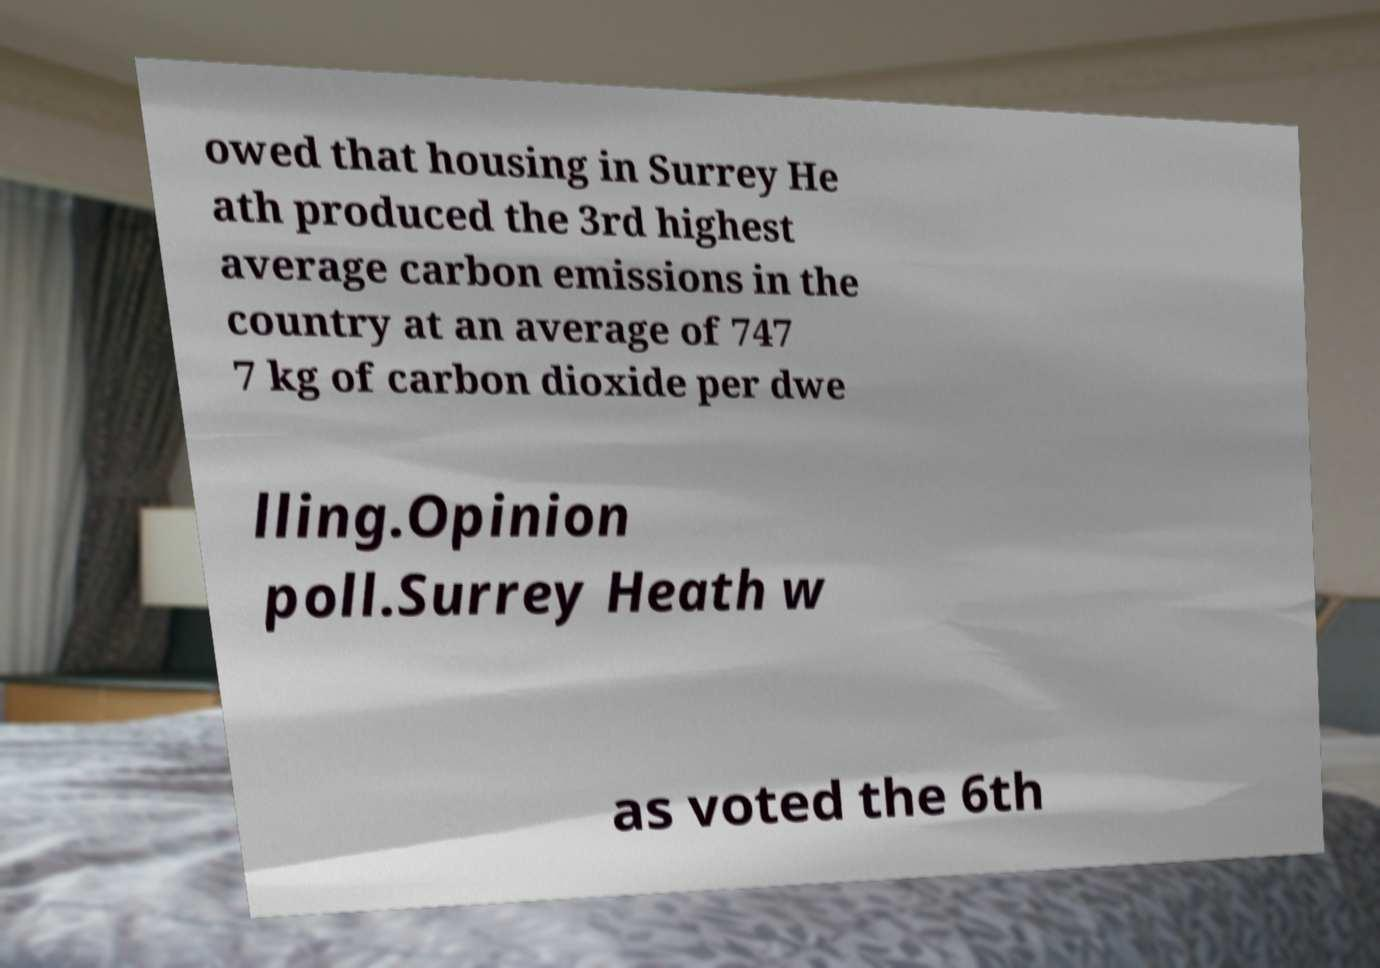Could you assist in decoding the text presented in this image and type it out clearly? owed that housing in Surrey He ath produced the 3rd highest average carbon emissions in the country at an average of 747 7 kg of carbon dioxide per dwe lling.Opinion poll.Surrey Heath w as voted the 6th 